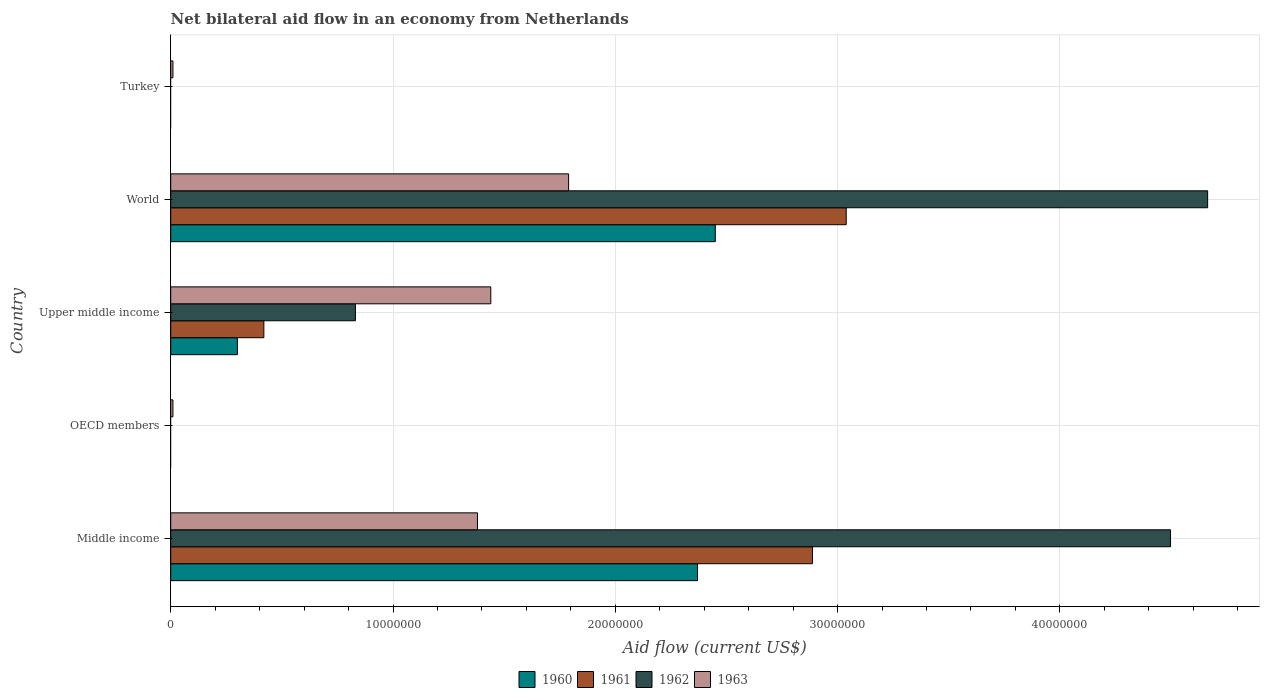Are the number of bars per tick equal to the number of legend labels?
Your response must be concise. No. Are the number of bars on each tick of the Y-axis equal?
Your answer should be very brief. No. What is the label of the 1st group of bars from the top?
Make the answer very short. Turkey. What is the net bilateral aid flow in 1962 in OECD members?
Ensure brevity in your answer.  0. Across all countries, what is the maximum net bilateral aid flow in 1961?
Offer a terse response. 3.04e+07. What is the total net bilateral aid flow in 1962 in the graph?
Offer a terse response. 9.99e+07. What is the difference between the net bilateral aid flow in 1961 in Middle income and that in Upper middle income?
Offer a terse response. 2.47e+07. What is the average net bilateral aid flow in 1960 per country?
Provide a succinct answer. 1.02e+07. What is the difference between the net bilateral aid flow in 1963 and net bilateral aid flow in 1962 in Middle income?
Your answer should be compact. -3.12e+07. What is the difference between the highest and the second highest net bilateral aid flow in 1962?
Make the answer very short. 1.67e+06. What is the difference between the highest and the lowest net bilateral aid flow in 1960?
Provide a succinct answer. 2.45e+07. In how many countries, is the net bilateral aid flow in 1963 greater than the average net bilateral aid flow in 1963 taken over all countries?
Offer a terse response. 3. Is it the case that in every country, the sum of the net bilateral aid flow in 1961 and net bilateral aid flow in 1960 is greater than the sum of net bilateral aid flow in 1963 and net bilateral aid flow in 1962?
Ensure brevity in your answer.  No. Is it the case that in every country, the sum of the net bilateral aid flow in 1963 and net bilateral aid flow in 1960 is greater than the net bilateral aid flow in 1962?
Your answer should be compact. No. Are the values on the major ticks of X-axis written in scientific E-notation?
Offer a very short reply. No. How are the legend labels stacked?
Offer a terse response. Horizontal. What is the title of the graph?
Provide a succinct answer. Net bilateral aid flow in an economy from Netherlands. Does "1988" appear as one of the legend labels in the graph?
Make the answer very short. No. What is the label or title of the X-axis?
Your response must be concise. Aid flow (current US$). What is the label or title of the Y-axis?
Your answer should be very brief. Country. What is the Aid flow (current US$) in 1960 in Middle income?
Make the answer very short. 2.37e+07. What is the Aid flow (current US$) of 1961 in Middle income?
Your answer should be very brief. 2.89e+07. What is the Aid flow (current US$) in 1962 in Middle income?
Your answer should be very brief. 4.50e+07. What is the Aid flow (current US$) of 1963 in Middle income?
Ensure brevity in your answer.  1.38e+07. What is the Aid flow (current US$) in 1961 in OECD members?
Offer a terse response. 0. What is the Aid flow (current US$) in 1963 in OECD members?
Your answer should be compact. 1.00e+05. What is the Aid flow (current US$) of 1961 in Upper middle income?
Ensure brevity in your answer.  4.19e+06. What is the Aid flow (current US$) of 1962 in Upper middle income?
Ensure brevity in your answer.  8.31e+06. What is the Aid flow (current US$) in 1963 in Upper middle income?
Offer a terse response. 1.44e+07. What is the Aid flow (current US$) of 1960 in World?
Ensure brevity in your answer.  2.45e+07. What is the Aid flow (current US$) of 1961 in World?
Your answer should be very brief. 3.04e+07. What is the Aid flow (current US$) in 1962 in World?
Offer a very short reply. 4.66e+07. What is the Aid flow (current US$) in 1963 in World?
Ensure brevity in your answer.  1.79e+07. What is the Aid flow (current US$) in 1960 in Turkey?
Ensure brevity in your answer.  0. What is the Aid flow (current US$) in 1962 in Turkey?
Make the answer very short. 0. What is the Aid flow (current US$) in 1963 in Turkey?
Your answer should be compact. 1.00e+05. Across all countries, what is the maximum Aid flow (current US$) in 1960?
Make the answer very short. 2.45e+07. Across all countries, what is the maximum Aid flow (current US$) of 1961?
Offer a terse response. 3.04e+07. Across all countries, what is the maximum Aid flow (current US$) of 1962?
Your response must be concise. 4.66e+07. Across all countries, what is the maximum Aid flow (current US$) of 1963?
Provide a short and direct response. 1.79e+07. Across all countries, what is the minimum Aid flow (current US$) of 1960?
Provide a short and direct response. 0. Across all countries, what is the minimum Aid flow (current US$) of 1961?
Provide a succinct answer. 0. What is the total Aid flow (current US$) of 1960 in the graph?
Provide a succinct answer. 5.12e+07. What is the total Aid flow (current US$) of 1961 in the graph?
Offer a very short reply. 6.34e+07. What is the total Aid flow (current US$) in 1962 in the graph?
Provide a short and direct response. 9.99e+07. What is the total Aid flow (current US$) in 1963 in the graph?
Offer a terse response. 4.63e+07. What is the difference between the Aid flow (current US$) in 1963 in Middle income and that in OECD members?
Your answer should be compact. 1.37e+07. What is the difference between the Aid flow (current US$) in 1960 in Middle income and that in Upper middle income?
Your answer should be very brief. 2.07e+07. What is the difference between the Aid flow (current US$) of 1961 in Middle income and that in Upper middle income?
Offer a terse response. 2.47e+07. What is the difference between the Aid flow (current US$) of 1962 in Middle income and that in Upper middle income?
Provide a short and direct response. 3.67e+07. What is the difference between the Aid flow (current US$) in 1963 in Middle income and that in Upper middle income?
Give a very brief answer. -6.00e+05. What is the difference between the Aid flow (current US$) in 1960 in Middle income and that in World?
Make the answer very short. -8.00e+05. What is the difference between the Aid flow (current US$) in 1961 in Middle income and that in World?
Keep it short and to the point. -1.52e+06. What is the difference between the Aid flow (current US$) in 1962 in Middle income and that in World?
Your answer should be compact. -1.67e+06. What is the difference between the Aid flow (current US$) of 1963 in Middle income and that in World?
Provide a succinct answer. -4.10e+06. What is the difference between the Aid flow (current US$) in 1963 in Middle income and that in Turkey?
Provide a short and direct response. 1.37e+07. What is the difference between the Aid flow (current US$) in 1963 in OECD members and that in Upper middle income?
Make the answer very short. -1.43e+07. What is the difference between the Aid flow (current US$) of 1963 in OECD members and that in World?
Your response must be concise. -1.78e+07. What is the difference between the Aid flow (current US$) of 1963 in OECD members and that in Turkey?
Ensure brevity in your answer.  0. What is the difference between the Aid flow (current US$) of 1960 in Upper middle income and that in World?
Ensure brevity in your answer.  -2.15e+07. What is the difference between the Aid flow (current US$) in 1961 in Upper middle income and that in World?
Offer a terse response. -2.62e+07. What is the difference between the Aid flow (current US$) in 1962 in Upper middle income and that in World?
Your response must be concise. -3.83e+07. What is the difference between the Aid flow (current US$) in 1963 in Upper middle income and that in World?
Ensure brevity in your answer.  -3.50e+06. What is the difference between the Aid flow (current US$) of 1963 in Upper middle income and that in Turkey?
Provide a succinct answer. 1.43e+07. What is the difference between the Aid flow (current US$) of 1963 in World and that in Turkey?
Ensure brevity in your answer.  1.78e+07. What is the difference between the Aid flow (current US$) of 1960 in Middle income and the Aid flow (current US$) of 1963 in OECD members?
Provide a succinct answer. 2.36e+07. What is the difference between the Aid flow (current US$) in 1961 in Middle income and the Aid flow (current US$) in 1963 in OECD members?
Give a very brief answer. 2.88e+07. What is the difference between the Aid flow (current US$) in 1962 in Middle income and the Aid flow (current US$) in 1963 in OECD members?
Offer a very short reply. 4.49e+07. What is the difference between the Aid flow (current US$) in 1960 in Middle income and the Aid flow (current US$) in 1961 in Upper middle income?
Provide a short and direct response. 1.95e+07. What is the difference between the Aid flow (current US$) of 1960 in Middle income and the Aid flow (current US$) of 1962 in Upper middle income?
Offer a terse response. 1.54e+07. What is the difference between the Aid flow (current US$) of 1960 in Middle income and the Aid flow (current US$) of 1963 in Upper middle income?
Keep it short and to the point. 9.30e+06. What is the difference between the Aid flow (current US$) of 1961 in Middle income and the Aid flow (current US$) of 1962 in Upper middle income?
Provide a succinct answer. 2.06e+07. What is the difference between the Aid flow (current US$) of 1961 in Middle income and the Aid flow (current US$) of 1963 in Upper middle income?
Offer a very short reply. 1.45e+07. What is the difference between the Aid flow (current US$) in 1962 in Middle income and the Aid flow (current US$) in 1963 in Upper middle income?
Keep it short and to the point. 3.06e+07. What is the difference between the Aid flow (current US$) in 1960 in Middle income and the Aid flow (current US$) in 1961 in World?
Offer a terse response. -6.69e+06. What is the difference between the Aid flow (current US$) in 1960 in Middle income and the Aid flow (current US$) in 1962 in World?
Provide a succinct answer. -2.30e+07. What is the difference between the Aid flow (current US$) of 1960 in Middle income and the Aid flow (current US$) of 1963 in World?
Offer a very short reply. 5.80e+06. What is the difference between the Aid flow (current US$) in 1961 in Middle income and the Aid flow (current US$) in 1962 in World?
Make the answer very short. -1.78e+07. What is the difference between the Aid flow (current US$) in 1961 in Middle income and the Aid flow (current US$) in 1963 in World?
Make the answer very short. 1.10e+07. What is the difference between the Aid flow (current US$) of 1962 in Middle income and the Aid flow (current US$) of 1963 in World?
Keep it short and to the point. 2.71e+07. What is the difference between the Aid flow (current US$) in 1960 in Middle income and the Aid flow (current US$) in 1963 in Turkey?
Offer a very short reply. 2.36e+07. What is the difference between the Aid flow (current US$) of 1961 in Middle income and the Aid flow (current US$) of 1963 in Turkey?
Give a very brief answer. 2.88e+07. What is the difference between the Aid flow (current US$) in 1962 in Middle income and the Aid flow (current US$) in 1963 in Turkey?
Give a very brief answer. 4.49e+07. What is the difference between the Aid flow (current US$) in 1960 in Upper middle income and the Aid flow (current US$) in 1961 in World?
Offer a very short reply. -2.74e+07. What is the difference between the Aid flow (current US$) in 1960 in Upper middle income and the Aid flow (current US$) in 1962 in World?
Provide a succinct answer. -4.36e+07. What is the difference between the Aid flow (current US$) of 1960 in Upper middle income and the Aid flow (current US$) of 1963 in World?
Offer a terse response. -1.49e+07. What is the difference between the Aid flow (current US$) in 1961 in Upper middle income and the Aid flow (current US$) in 1962 in World?
Your response must be concise. -4.25e+07. What is the difference between the Aid flow (current US$) in 1961 in Upper middle income and the Aid flow (current US$) in 1963 in World?
Provide a short and direct response. -1.37e+07. What is the difference between the Aid flow (current US$) of 1962 in Upper middle income and the Aid flow (current US$) of 1963 in World?
Ensure brevity in your answer.  -9.59e+06. What is the difference between the Aid flow (current US$) of 1960 in Upper middle income and the Aid flow (current US$) of 1963 in Turkey?
Your answer should be very brief. 2.90e+06. What is the difference between the Aid flow (current US$) of 1961 in Upper middle income and the Aid flow (current US$) of 1963 in Turkey?
Make the answer very short. 4.09e+06. What is the difference between the Aid flow (current US$) of 1962 in Upper middle income and the Aid flow (current US$) of 1963 in Turkey?
Offer a very short reply. 8.21e+06. What is the difference between the Aid flow (current US$) of 1960 in World and the Aid flow (current US$) of 1963 in Turkey?
Offer a terse response. 2.44e+07. What is the difference between the Aid flow (current US$) of 1961 in World and the Aid flow (current US$) of 1963 in Turkey?
Your answer should be compact. 3.03e+07. What is the difference between the Aid flow (current US$) of 1962 in World and the Aid flow (current US$) of 1963 in Turkey?
Provide a short and direct response. 4.66e+07. What is the average Aid flow (current US$) in 1960 per country?
Provide a short and direct response. 1.02e+07. What is the average Aid flow (current US$) of 1961 per country?
Ensure brevity in your answer.  1.27e+07. What is the average Aid flow (current US$) in 1962 per country?
Your answer should be compact. 2.00e+07. What is the average Aid flow (current US$) of 1963 per country?
Provide a succinct answer. 9.26e+06. What is the difference between the Aid flow (current US$) of 1960 and Aid flow (current US$) of 1961 in Middle income?
Your answer should be compact. -5.17e+06. What is the difference between the Aid flow (current US$) of 1960 and Aid flow (current US$) of 1962 in Middle income?
Make the answer very short. -2.13e+07. What is the difference between the Aid flow (current US$) in 1960 and Aid flow (current US$) in 1963 in Middle income?
Your answer should be very brief. 9.90e+06. What is the difference between the Aid flow (current US$) of 1961 and Aid flow (current US$) of 1962 in Middle income?
Give a very brief answer. -1.61e+07. What is the difference between the Aid flow (current US$) in 1961 and Aid flow (current US$) in 1963 in Middle income?
Your answer should be compact. 1.51e+07. What is the difference between the Aid flow (current US$) in 1962 and Aid flow (current US$) in 1963 in Middle income?
Your answer should be compact. 3.12e+07. What is the difference between the Aid flow (current US$) in 1960 and Aid flow (current US$) in 1961 in Upper middle income?
Provide a short and direct response. -1.19e+06. What is the difference between the Aid flow (current US$) in 1960 and Aid flow (current US$) in 1962 in Upper middle income?
Provide a succinct answer. -5.31e+06. What is the difference between the Aid flow (current US$) of 1960 and Aid flow (current US$) of 1963 in Upper middle income?
Your answer should be compact. -1.14e+07. What is the difference between the Aid flow (current US$) in 1961 and Aid flow (current US$) in 1962 in Upper middle income?
Ensure brevity in your answer.  -4.12e+06. What is the difference between the Aid flow (current US$) in 1961 and Aid flow (current US$) in 1963 in Upper middle income?
Provide a succinct answer. -1.02e+07. What is the difference between the Aid flow (current US$) of 1962 and Aid flow (current US$) of 1963 in Upper middle income?
Make the answer very short. -6.09e+06. What is the difference between the Aid flow (current US$) in 1960 and Aid flow (current US$) in 1961 in World?
Offer a very short reply. -5.89e+06. What is the difference between the Aid flow (current US$) of 1960 and Aid flow (current US$) of 1962 in World?
Your answer should be very brief. -2.22e+07. What is the difference between the Aid flow (current US$) in 1960 and Aid flow (current US$) in 1963 in World?
Your answer should be compact. 6.60e+06. What is the difference between the Aid flow (current US$) in 1961 and Aid flow (current US$) in 1962 in World?
Provide a short and direct response. -1.63e+07. What is the difference between the Aid flow (current US$) in 1961 and Aid flow (current US$) in 1963 in World?
Your response must be concise. 1.25e+07. What is the difference between the Aid flow (current US$) of 1962 and Aid flow (current US$) of 1963 in World?
Your answer should be very brief. 2.88e+07. What is the ratio of the Aid flow (current US$) of 1963 in Middle income to that in OECD members?
Your answer should be compact. 138. What is the ratio of the Aid flow (current US$) in 1961 in Middle income to that in Upper middle income?
Your answer should be very brief. 6.89. What is the ratio of the Aid flow (current US$) of 1962 in Middle income to that in Upper middle income?
Your answer should be very brief. 5.41. What is the ratio of the Aid flow (current US$) in 1963 in Middle income to that in Upper middle income?
Offer a terse response. 0.96. What is the ratio of the Aid flow (current US$) of 1960 in Middle income to that in World?
Provide a succinct answer. 0.97. What is the ratio of the Aid flow (current US$) of 1961 in Middle income to that in World?
Offer a very short reply. 0.95. What is the ratio of the Aid flow (current US$) of 1962 in Middle income to that in World?
Ensure brevity in your answer.  0.96. What is the ratio of the Aid flow (current US$) in 1963 in Middle income to that in World?
Offer a very short reply. 0.77. What is the ratio of the Aid flow (current US$) in 1963 in Middle income to that in Turkey?
Offer a terse response. 138. What is the ratio of the Aid flow (current US$) of 1963 in OECD members to that in Upper middle income?
Offer a very short reply. 0.01. What is the ratio of the Aid flow (current US$) in 1963 in OECD members to that in World?
Your answer should be compact. 0.01. What is the ratio of the Aid flow (current US$) in 1963 in OECD members to that in Turkey?
Your answer should be compact. 1. What is the ratio of the Aid flow (current US$) of 1960 in Upper middle income to that in World?
Offer a very short reply. 0.12. What is the ratio of the Aid flow (current US$) of 1961 in Upper middle income to that in World?
Your response must be concise. 0.14. What is the ratio of the Aid flow (current US$) of 1962 in Upper middle income to that in World?
Your response must be concise. 0.18. What is the ratio of the Aid flow (current US$) of 1963 in Upper middle income to that in World?
Your response must be concise. 0.8. What is the ratio of the Aid flow (current US$) in 1963 in Upper middle income to that in Turkey?
Offer a very short reply. 144. What is the ratio of the Aid flow (current US$) of 1963 in World to that in Turkey?
Make the answer very short. 179. What is the difference between the highest and the second highest Aid flow (current US$) of 1960?
Your response must be concise. 8.00e+05. What is the difference between the highest and the second highest Aid flow (current US$) in 1961?
Offer a very short reply. 1.52e+06. What is the difference between the highest and the second highest Aid flow (current US$) in 1962?
Your answer should be compact. 1.67e+06. What is the difference between the highest and the second highest Aid flow (current US$) in 1963?
Provide a succinct answer. 3.50e+06. What is the difference between the highest and the lowest Aid flow (current US$) in 1960?
Your answer should be very brief. 2.45e+07. What is the difference between the highest and the lowest Aid flow (current US$) in 1961?
Your answer should be very brief. 3.04e+07. What is the difference between the highest and the lowest Aid flow (current US$) of 1962?
Your response must be concise. 4.66e+07. What is the difference between the highest and the lowest Aid flow (current US$) of 1963?
Make the answer very short. 1.78e+07. 